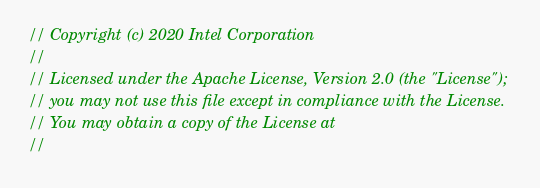Convert code to text. <code><loc_0><loc_0><loc_500><loc_500><_C++_>// Copyright (c) 2020 Intel Corporation
//
// Licensed under the Apache License, Version 2.0 (the "License");
// you may not use this file except in compliance with the License.
// You may obtain a copy of the License at
//</code> 